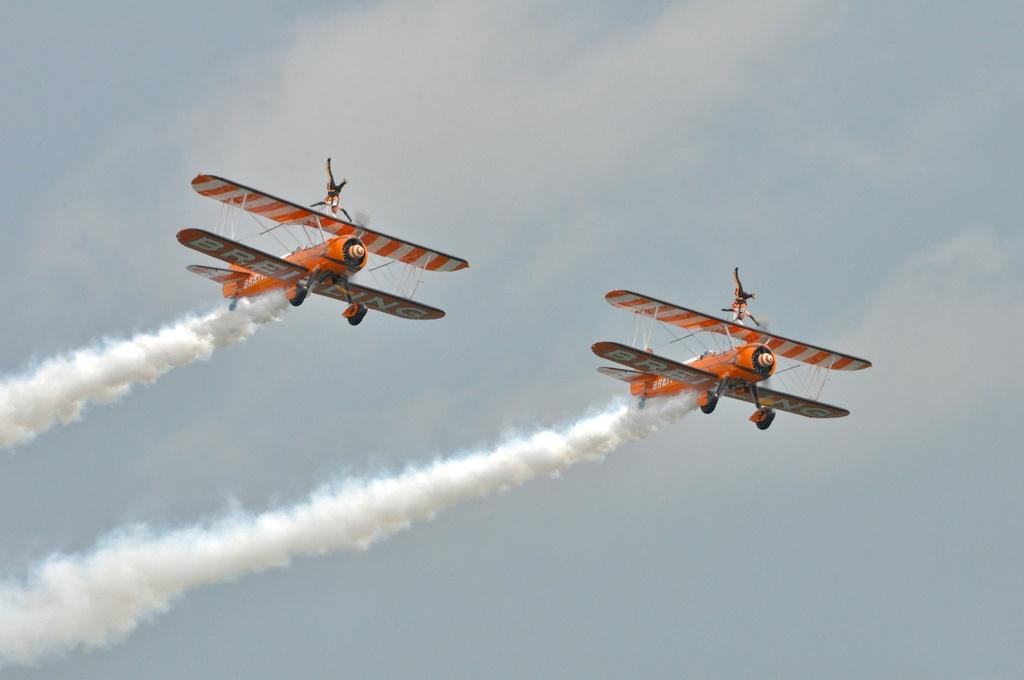What is the main subject of the image? The main subject of the image is two aircraft. What are the aircraft doing in the image? The aircraft are flying in the sky. What can be seen behind the aircraft as they fly? The aircraft are leaving smoke behind them. Can you see a frog wearing shoes in the image? No, there is no frog or shoes present in the image. What type of bear can be seen interacting with the aircraft in the image? There is no bear present in the image; the main subjects are the two aircraft. 